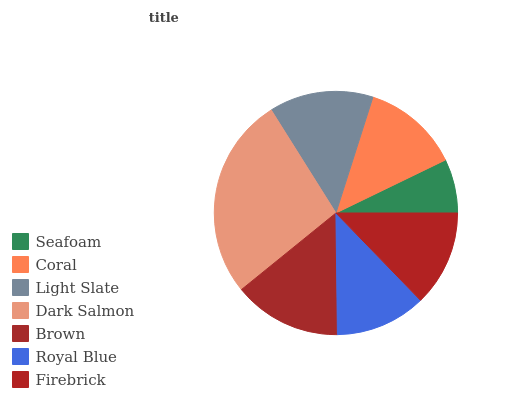Is Seafoam the minimum?
Answer yes or no. Yes. Is Dark Salmon the maximum?
Answer yes or no. Yes. Is Coral the minimum?
Answer yes or no. No. Is Coral the maximum?
Answer yes or no. No. Is Coral greater than Seafoam?
Answer yes or no. Yes. Is Seafoam less than Coral?
Answer yes or no. Yes. Is Seafoam greater than Coral?
Answer yes or no. No. Is Coral less than Seafoam?
Answer yes or no. No. Is Coral the high median?
Answer yes or no. Yes. Is Coral the low median?
Answer yes or no. Yes. Is Seafoam the high median?
Answer yes or no. No. Is Firebrick the low median?
Answer yes or no. No. 